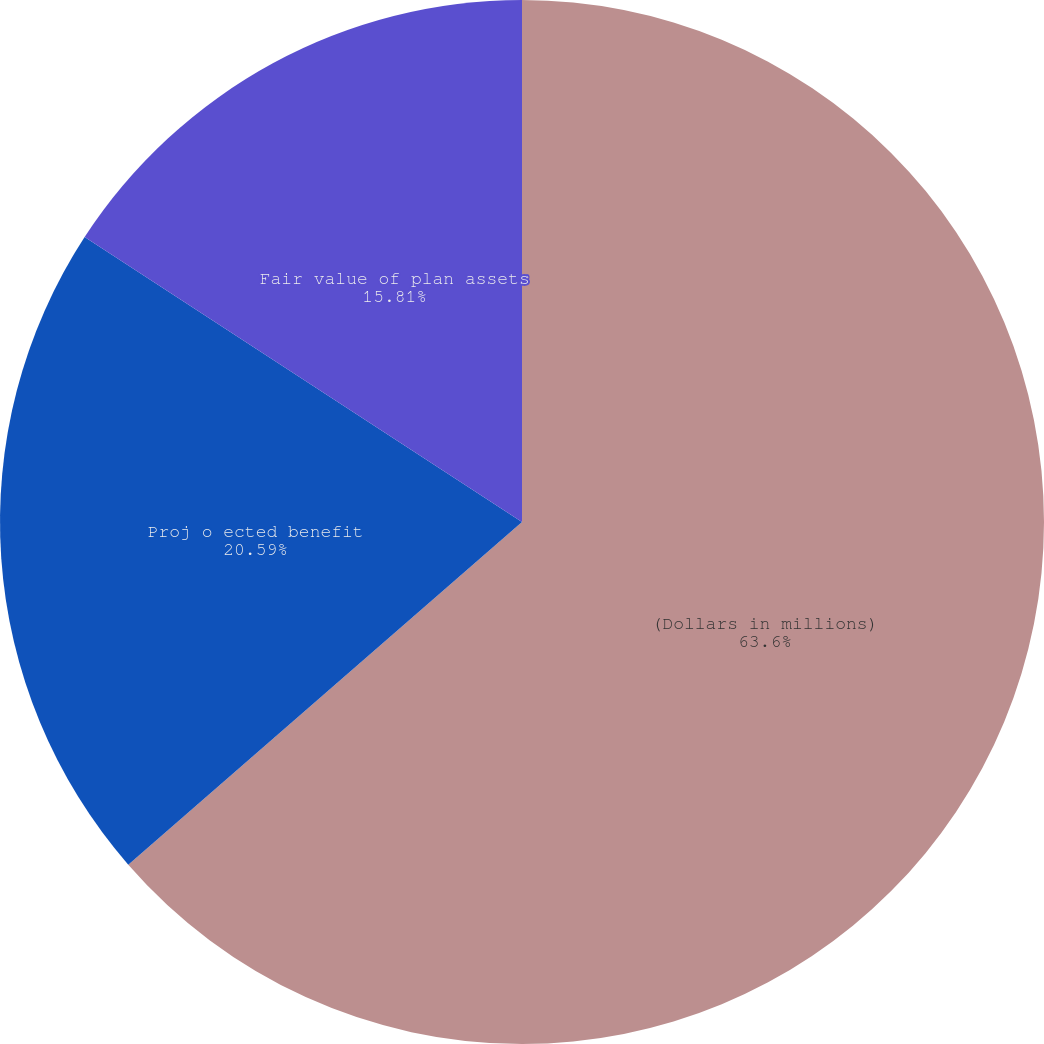<chart> <loc_0><loc_0><loc_500><loc_500><pie_chart><fcel>(Dollars in millions)<fcel>Proj o ected benefit<fcel>Fair value of plan assets<nl><fcel>63.6%<fcel>20.59%<fcel>15.81%<nl></chart> 